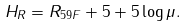<formula> <loc_0><loc_0><loc_500><loc_500>H _ { R } = R _ { 5 9 F } + 5 + 5 \log \mu .</formula> 